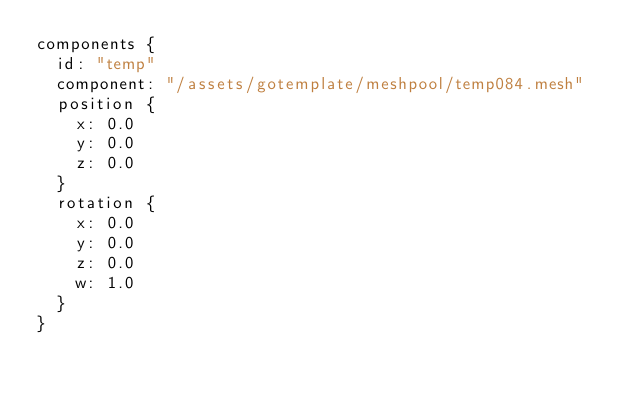Convert code to text. <code><loc_0><loc_0><loc_500><loc_500><_Go_>components {
  id: "temp"
  component: "/assets/gotemplate/meshpool/temp084.mesh"
  position {
    x: 0.0
    y: 0.0
    z: 0.0
  }
  rotation {
    x: 0.0
    y: 0.0
    z: 0.0
    w: 1.0
  }
}
</code> 